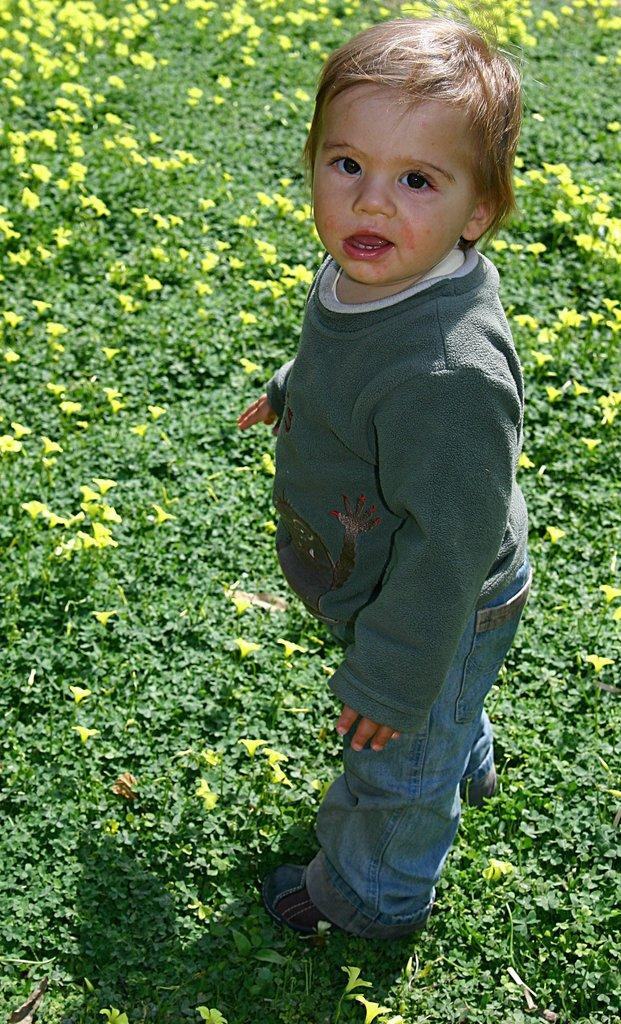What is the main subject of the image? The main subject of the image is a kid. What is the kid doing in the image? The kid is standing on the ground in the image. What type of vegetation can be seen in the image? There are plants and flowers in the image. What is the kid wearing in the image? The kid is wearing a grey T-shirt and blue jeans pants. Can you tell me which vein the kid is holding in the image? There is no vein present in the image; it features a kid standing among plants and flowers. What type of instrument is the kid playing in the image? There is no instrument present in the image; the kid is simply standing on the ground. 